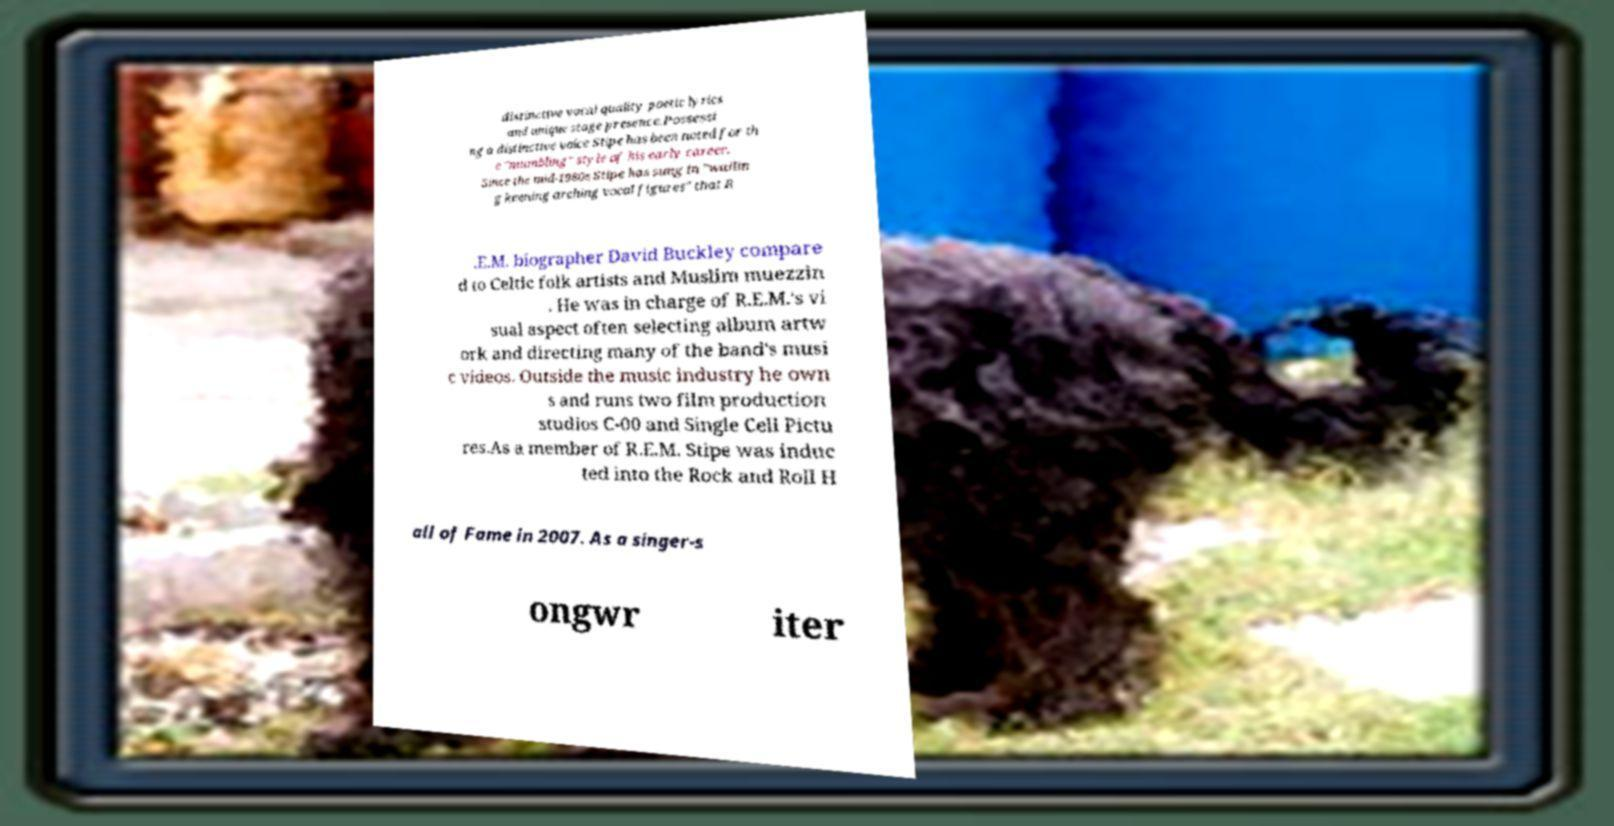Could you assist in decoding the text presented in this image and type it out clearly? distinctive vocal quality poetic lyrics and unique stage presence.Possessi ng a distinctive voice Stipe has been noted for th e "mumbling" style of his early career. Since the mid-1980s Stipe has sung in "wailin g keening arching vocal figures" that R .E.M. biographer David Buckley compare d to Celtic folk artists and Muslim muezzin . He was in charge of R.E.M.'s vi sual aspect often selecting album artw ork and directing many of the band's musi c videos. Outside the music industry he own s and runs two film production studios C-00 and Single Cell Pictu res.As a member of R.E.M. Stipe was induc ted into the Rock and Roll H all of Fame in 2007. As a singer-s ongwr iter 